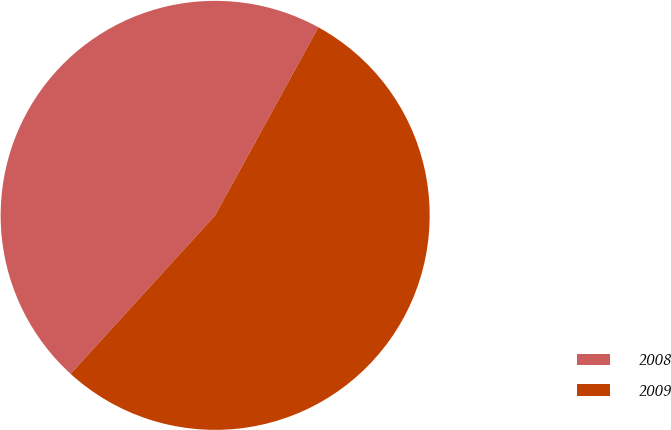Convert chart to OTSL. <chart><loc_0><loc_0><loc_500><loc_500><pie_chart><fcel>2008<fcel>2009<nl><fcel>46.22%<fcel>53.78%<nl></chart> 